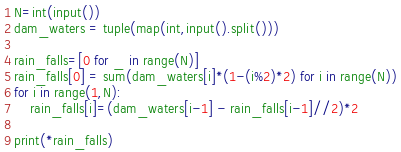Convert code to text. <code><loc_0><loc_0><loc_500><loc_500><_Python_>N=int(input())
dam_waters = tuple(map(int,input().split()))

rain_falls=[0 for _ in range(N)]
rain_falls[0] = sum(dam_waters[i]*(1-(i%2)*2) for i in range(N))
for i in range(1,N):
    rain_falls[i]=(dam_waters[i-1] - rain_falls[i-1]//2)*2

print(*rain_falls)</code> 